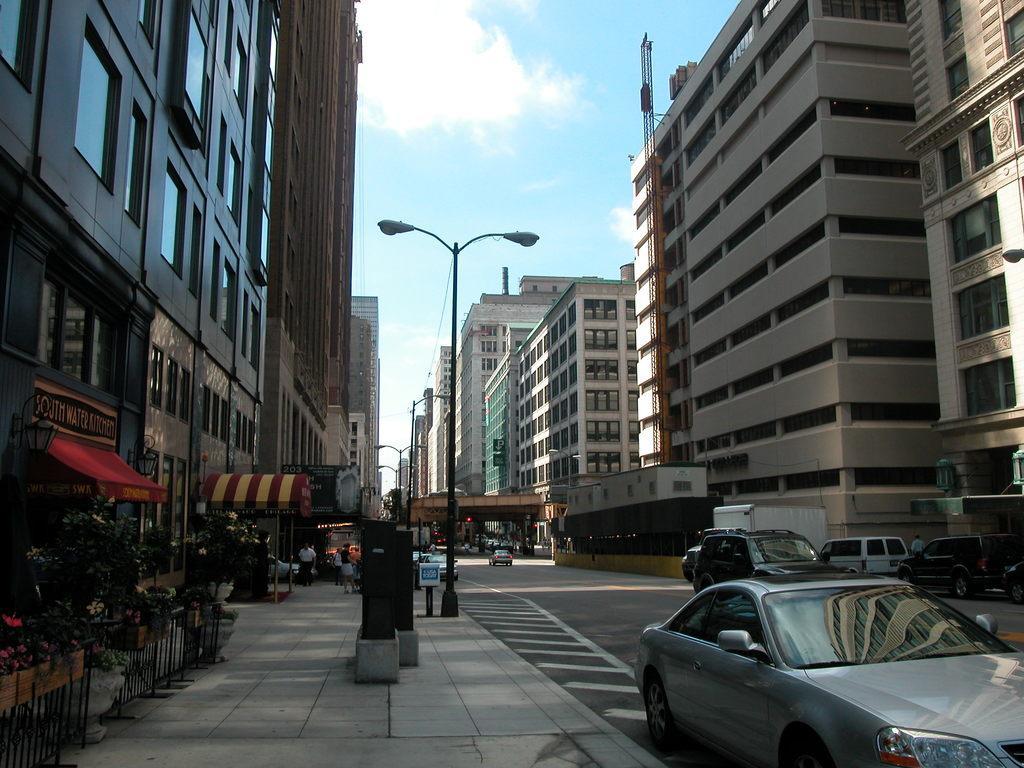Could you give a brief overview of what you see in this image? In this picture we can see some vehicles on the road. On the left side of the vehicles there are some people standing on the walkway. On the left side of the people there are plants, iron grilles and on the right side of the people there are poles with lights. On the left and right side of the poles there are buildings with a name board. Behind the building there is the sky. 